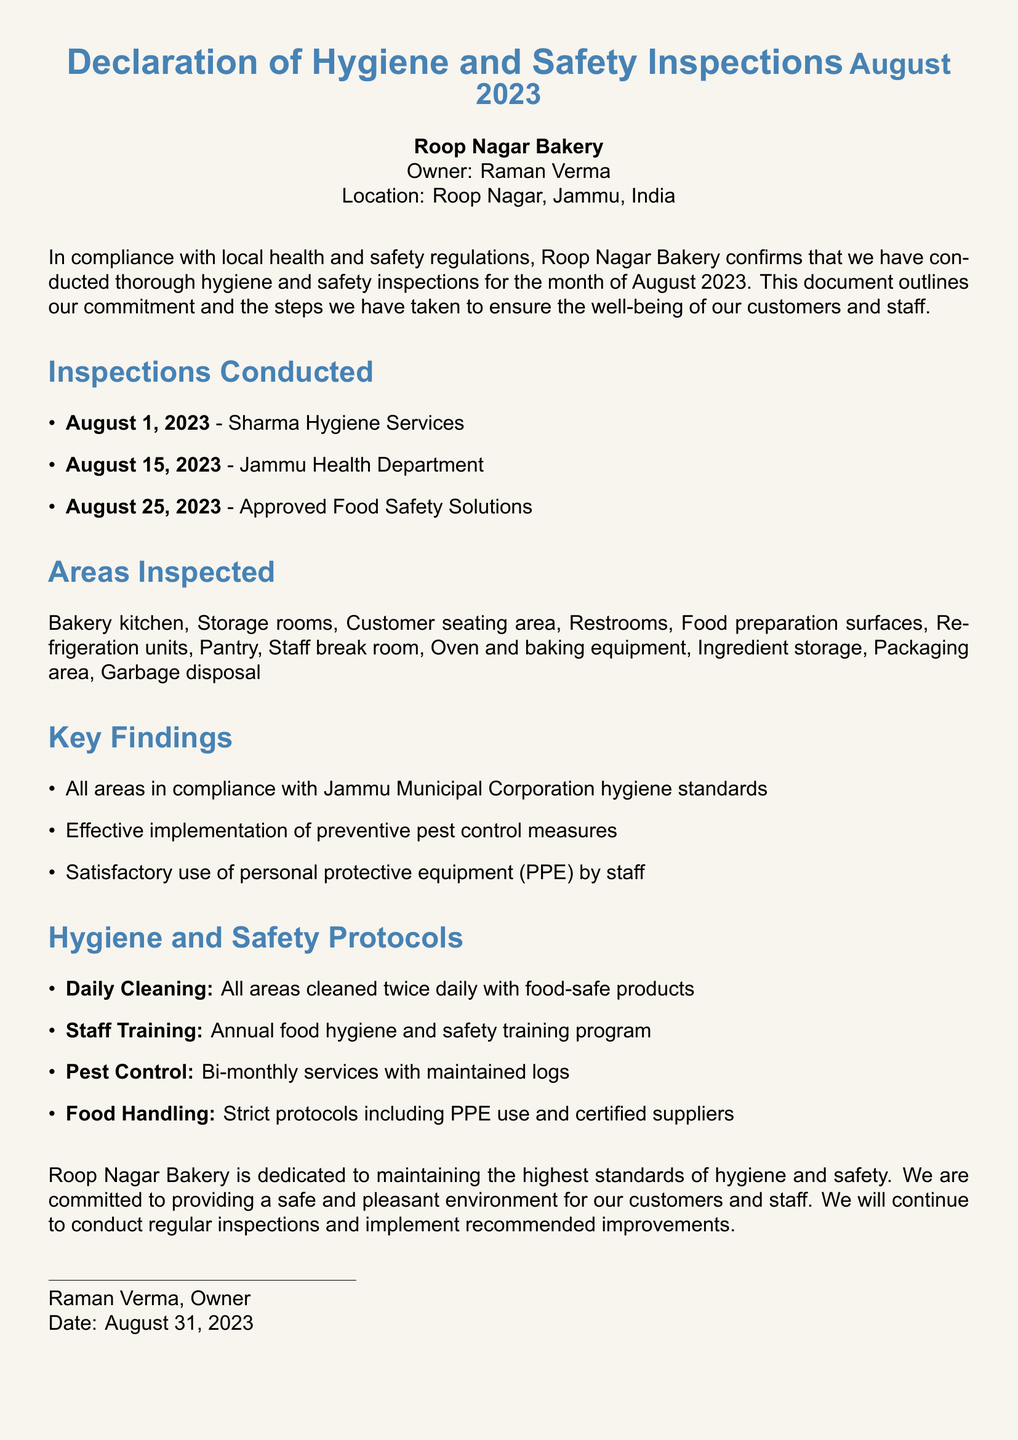what is the name of the bakery? The name of the bakery is mentioned at the beginning of the declaration document.
Answer: Roop Nagar Bakery who is the owner of the bakery? The owner's name is provided in the declaration section of the document.
Answer: Raman Verma when was the first inspection conducted? The date of the first inspection is listed in the inspections conducted section.
Answer: August 1, 2023 how many inspections were conducted in August 2023? The total number of inspections is indicated by the items listed in the inspections conducted section.
Answer: 3 what area was inspected for food preparation? The specific area related to food preparation is included in the areas inspected section.
Answer: Food preparation surfaces which organization conducted the second inspection? The second inspection organization is detailed under the inspections conducted section.
Answer: Jammu Health Department what type of cleaning frequency is mentioned? The cleaning frequency is specified in the hygiene and safety protocols section.
Answer: Daily Cleaning what safety protocol involves personal protective equipment? The related safety protocol is highlighted under the hygiene and safety protocols.
Answer: Food Handling were there any non-compliance issues reported? The key findings section indicates overall compliance status.
Answer: No 